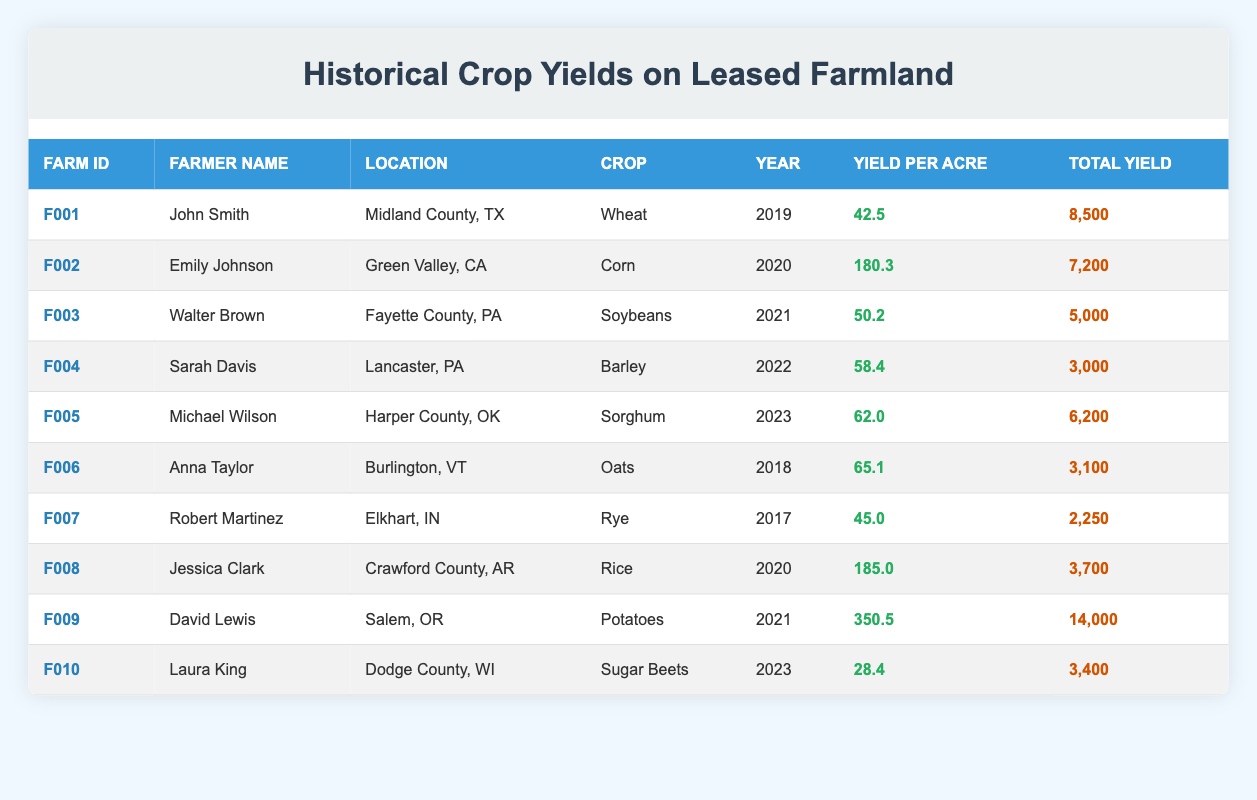What was the yield per acre for the crop grown by John Smith in 2019? According to the table, John Smith's crop yield in 2019 for Wheat was 42.5.
Answer: 42.5 Which farmer had the highest total yield, and what was that yield? The table shows that David Lewis had the highest total yield of 14,000 for Potatoes in 2021.
Answer: David Lewis, 14,000 In what year did Emily Johnson grow Corn, and how much was her yield per acre? Emily Johnson grew Corn in 2020, with a yield per acre of 180.3 as per the table.
Answer: 2020, 180.3 What is the average yield per acre for the crops grown by farmers in 2022? The crops grown in 2022 are Barley by Sarah Davis with 58.4. Since there is only one entry for 2022, the average yield per acre is 58.4.
Answer: 58.4 Did any farmer have a total yield greater than 10,000? Looking through the table, the only total yield that exceeds 10,000 is David Lewis's 14,000. Therefore, yes, there was a farmer with a total yield greater than 10,000.
Answer: Yes What is the difference in yield per acre between the crop grown by David Lewis and the crop grown by Sarah Davis? David Lewis had a yield per acre of 350.5 for Potatoes, and Sarah Davis had a yield of 58.4 for Barley. The difference is calculated as 350.5 - 58.4 = 292.1.
Answer: 292.1 Which crop had the lowest yield per acre, and who was the farmer? Looking at the table, Laura King had the lowest yield per acre of 28.4 for Sugar Beets in 2023.
Answer: Sugar Beets, Laura King How many farmers grew crops with a yield per acre of 60 or more? The crops with a yield per acre of 60 or more were grown by Anna Taylor (65.1), Michael Wilson (62.0), and David Lewis (350.5). Thus, there are three farmers who grew crops with such yields.
Answer: 3 In which location did Robert Martinez grow Rye, and what was the total yield? Robert Martinez grew Rye in Elkhart, IN, with a total yield of 2,250 according to the table.
Answer: Elkhart, IN, 2,250 